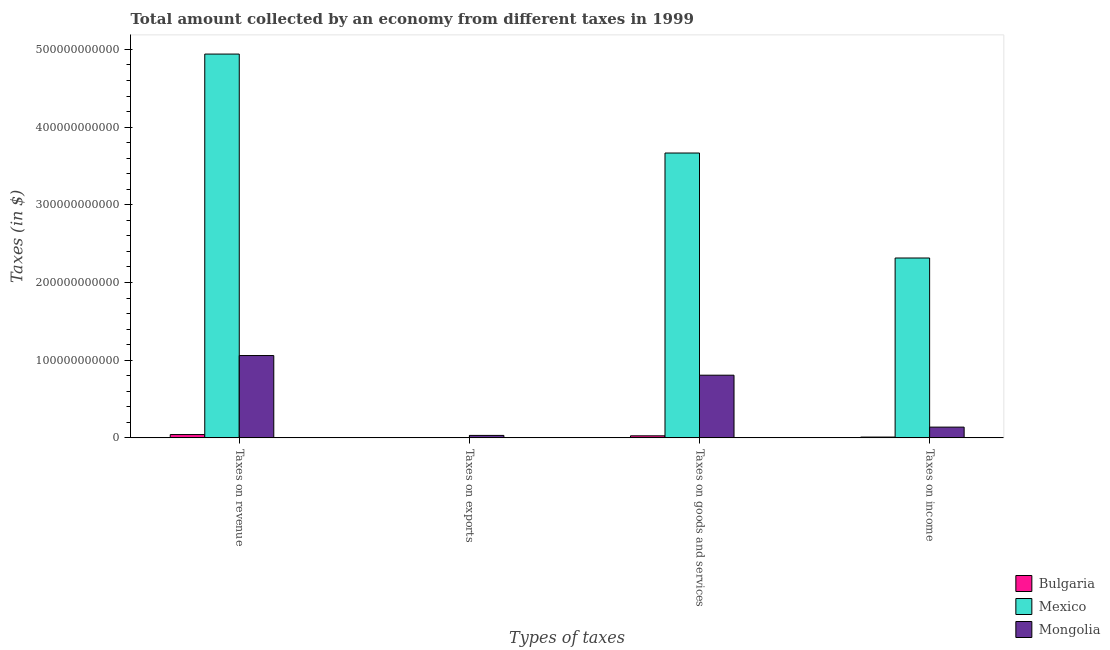How many different coloured bars are there?
Give a very brief answer. 3. How many groups of bars are there?
Your response must be concise. 4. How many bars are there on the 1st tick from the left?
Offer a terse response. 3. How many bars are there on the 1st tick from the right?
Provide a succinct answer. 3. What is the label of the 2nd group of bars from the left?
Keep it short and to the point. Taxes on exports. What is the amount collected as tax on revenue in Mongolia?
Your answer should be compact. 1.06e+11. Across all countries, what is the maximum amount collected as tax on goods?
Give a very brief answer. 3.67e+11. Across all countries, what is the minimum amount collected as tax on income?
Your answer should be compact. 1.03e+09. In which country was the amount collected as tax on exports minimum?
Offer a terse response. Bulgaria. What is the total amount collected as tax on exports in the graph?
Keep it short and to the point. 3.16e+09. What is the difference between the amount collected as tax on income in Mexico and that in Bulgaria?
Your response must be concise. 2.30e+11. What is the difference between the amount collected as tax on goods in Mexico and the amount collected as tax on income in Bulgaria?
Provide a succinct answer. 3.66e+11. What is the average amount collected as tax on revenue per country?
Offer a terse response. 2.01e+11. What is the difference between the amount collected as tax on income and amount collected as tax on revenue in Mongolia?
Ensure brevity in your answer.  -9.21e+1. What is the ratio of the amount collected as tax on income in Bulgaria to that in Mexico?
Make the answer very short. 0. What is the difference between the highest and the second highest amount collected as tax on revenue?
Provide a succinct answer. 3.88e+11. What is the difference between the highest and the lowest amount collected as tax on exports?
Ensure brevity in your answer.  3.16e+09. Is it the case that in every country, the sum of the amount collected as tax on exports and amount collected as tax on revenue is greater than the sum of amount collected as tax on goods and amount collected as tax on income?
Offer a very short reply. No. What does the 3rd bar from the left in Taxes on goods and services represents?
Offer a terse response. Mongolia. What does the 1st bar from the right in Taxes on income represents?
Offer a terse response. Mongolia. Is it the case that in every country, the sum of the amount collected as tax on revenue and amount collected as tax on exports is greater than the amount collected as tax on goods?
Your response must be concise. Yes. Are all the bars in the graph horizontal?
Offer a very short reply. No. What is the difference between two consecutive major ticks on the Y-axis?
Your answer should be compact. 1.00e+11. Does the graph contain grids?
Give a very brief answer. No. What is the title of the graph?
Keep it short and to the point. Total amount collected by an economy from different taxes in 1999. Does "Bhutan" appear as one of the legend labels in the graph?
Your response must be concise. No. What is the label or title of the X-axis?
Give a very brief answer. Types of taxes. What is the label or title of the Y-axis?
Your answer should be compact. Taxes (in $). What is the Taxes (in $) in Bulgaria in Taxes on revenue?
Your answer should be very brief. 4.26e+09. What is the Taxes (in $) of Mexico in Taxes on revenue?
Provide a succinct answer. 4.94e+11. What is the Taxes (in $) of Mongolia in Taxes on revenue?
Your answer should be compact. 1.06e+11. What is the Taxes (in $) in Bulgaria in Taxes on exports?
Offer a very short reply. 6.80e+04. What is the Taxes (in $) in Mexico in Taxes on exports?
Provide a short and direct response. 1.00e+06. What is the Taxes (in $) of Mongolia in Taxes on exports?
Offer a very short reply. 3.16e+09. What is the Taxes (in $) in Bulgaria in Taxes on goods and services?
Give a very brief answer. 2.63e+09. What is the Taxes (in $) of Mexico in Taxes on goods and services?
Make the answer very short. 3.67e+11. What is the Taxes (in $) of Mongolia in Taxes on goods and services?
Your answer should be very brief. 8.07e+1. What is the Taxes (in $) in Bulgaria in Taxes on income?
Provide a succinct answer. 1.03e+09. What is the Taxes (in $) in Mexico in Taxes on income?
Make the answer very short. 2.31e+11. What is the Taxes (in $) of Mongolia in Taxes on income?
Your answer should be compact. 1.38e+1. Across all Types of taxes, what is the maximum Taxes (in $) in Bulgaria?
Provide a short and direct response. 4.26e+09. Across all Types of taxes, what is the maximum Taxes (in $) of Mexico?
Offer a terse response. 4.94e+11. Across all Types of taxes, what is the maximum Taxes (in $) in Mongolia?
Offer a very short reply. 1.06e+11. Across all Types of taxes, what is the minimum Taxes (in $) of Bulgaria?
Provide a short and direct response. 6.80e+04. Across all Types of taxes, what is the minimum Taxes (in $) of Mongolia?
Give a very brief answer. 3.16e+09. What is the total Taxes (in $) in Bulgaria in the graph?
Give a very brief answer. 7.92e+09. What is the total Taxes (in $) of Mexico in the graph?
Your response must be concise. 1.09e+12. What is the total Taxes (in $) in Mongolia in the graph?
Keep it short and to the point. 2.04e+11. What is the difference between the Taxes (in $) of Bulgaria in Taxes on revenue and that in Taxes on exports?
Provide a short and direct response. 4.26e+09. What is the difference between the Taxes (in $) in Mexico in Taxes on revenue and that in Taxes on exports?
Offer a terse response. 4.94e+11. What is the difference between the Taxes (in $) in Mongolia in Taxes on revenue and that in Taxes on exports?
Your answer should be compact. 1.03e+11. What is the difference between the Taxes (in $) in Bulgaria in Taxes on revenue and that in Taxes on goods and services?
Ensure brevity in your answer.  1.63e+09. What is the difference between the Taxes (in $) of Mexico in Taxes on revenue and that in Taxes on goods and services?
Ensure brevity in your answer.  1.27e+11. What is the difference between the Taxes (in $) of Mongolia in Taxes on revenue and that in Taxes on goods and services?
Make the answer very short. 2.53e+1. What is the difference between the Taxes (in $) of Bulgaria in Taxes on revenue and that in Taxes on income?
Provide a short and direct response. 3.23e+09. What is the difference between the Taxes (in $) of Mexico in Taxes on revenue and that in Taxes on income?
Your answer should be compact. 2.62e+11. What is the difference between the Taxes (in $) of Mongolia in Taxes on revenue and that in Taxes on income?
Your answer should be very brief. 9.21e+1. What is the difference between the Taxes (in $) in Bulgaria in Taxes on exports and that in Taxes on goods and services?
Make the answer very short. -2.63e+09. What is the difference between the Taxes (in $) in Mexico in Taxes on exports and that in Taxes on goods and services?
Keep it short and to the point. -3.67e+11. What is the difference between the Taxes (in $) of Mongolia in Taxes on exports and that in Taxes on goods and services?
Provide a succinct answer. -7.75e+1. What is the difference between the Taxes (in $) of Bulgaria in Taxes on exports and that in Taxes on income?
Provide a short and direct response. -1.03e+09. What is the difference between the Taxes (in $) in Mexico in Taxes on exports and that in Taxes on income?
Offer a very short reply. -2.31e+11. What is the difference between the Taxes (in $) in Mongolia in Taxes on exports and that in Taxes on income?
Your answer should be compact. -1.07e+1. What is the difference between the Taxes (in $) of Bulgaria in Taxes on goods and services and that in Taxes on income?
Offer a very short reply. 1.60e+09. What is the difference between the Taxes (in $) of Mexico in Taxes on goods and services and that in Taxes on income?
Offer a very short reply. 1.35e+11. What is the difference between the Taxes (in $) of Mongolia in Taxes on goods and services and that in Taxes on income?
Keep it short and to the point. 6.68e+1. What is the difference between the Taxes (in $) in Bulgaria in Taxes on revenue and the Taxes (in $) in Mexico in Taxes on exports?
Provide a short and direct response. 4.26e+09. What is the difference between the Taxes (in $) in Bulgaria in Taxes on revenue and the Taxes (in $) in Mongolia in Taxes on exports?
Make the answer very short. 1.10e+09. What is the difference between the Taxes (in $) in Mexico in Taxes on revenue and the Taxes (in $) in Mongolia in Taxes on exports?
Offer a terse response. 4.91e+11. What is the difference between the Taxes (in $) of Bulgaria in Taxes on revenue and the Taxes (in $) of Mexico in Taxes on goods and services?
Keep it short and to the point. -3.62e+11. What is the difference between the Taxes (in $) in Bulgaria in Taxes on revenue and the Taxes (in $) in Mongolia in Taxes on goods and services?
Your answer should be compact. -7.64e+1. What is the difference between the Taxes (in $) in Mexico in Taxes on revenue and the Taxes (in $) in Mongolia in Taxes on goods and services?
Ensure brevity in your answer.  4.13e+11. What is the difference between the Taxes (in $) of Bulgaria in Taxes on revenue and the Taxes (in $) of Mexico in Taxes on income?
Your answer should be very brief. -2.27e+11. What is the difference between the Taxes (in $) of Bulgaria in Taxes on revenue and the Taxes (in $) of Mongolia in Taxes on income?
Your response must be concise. -9.58e+09. What is the difference between the Taxes (in $) in Mexico in Taxes on revenue and the Taxes (in $) in Mongolia in Taxes on income?
Your answer should be compact. 4.80e+11. What is the difference between the Taxes (in $) in Bulgaria in Taxes on exports and the Taxes (in $) in Mexico in Taxes on goods and services?
Provide a succinct answer. -3.67e+11. What is the difference between the Taxes (in $) in Bulgaria in Taxes on exports and the Taxes (in $) in Mongolia in Taxes on goods and services?
Offer a terse response. -8.07e+1. What is the difference between the Taxes (in $) of Mexico in Taxes on exports and the Taxes (in $) of Mongolia in Taxes on goods and services?
Provide a short and direct response. -8.07e+1. What is the difference between the Taxes (in $) in Bulgaria in Taxes on exports and the Taxes (in $) in Mexico in Taxes on income?
Offer a terse response. -2.31e+11. What is the difference between the Taxes (in $) of Bulgaria in Taxes on exports and the Taxes (in $) of Mongolia in Taxes on income?
Your answer should be compact. -1.38e+1. What is the difference between the Taxes (in $) in Mexico in Taxes on exports and the Taxes (in $) in Mongolia in Taxes on income?
Give a very brief answer. -1.38e+1. What is the difference between the Taxes (in $) in Bulgaria in Taxes on goods and services and the Taxes (in $) in Mexico in Taxes on income?
Your answer should be compact. -2.29e+11. What is the difference between the Taxes (in $) in Bulgaria in Taxes on goods and services and the Taxes (in $) in Mongolia in Taxes on income?
Offer a very short reply. -1.12e+1. What is the difference between the Taxes (in $) in Mexico in Taxes on goods and services and the Taxes (in $) in Mongolia in Taxes on income?
Ensure brevity in your answer.  3.53e+11. What is the average Taxes (in $) of Bulgaria per Types of taxes?
Keep it short and to the point. 1.98e+09. What is the average Taxes (in $) of Mexico per Types of taxes?
Keep it short and to the point. 2.73e+11. What is the average Taxes (in $) of Mongolia per Types of taxes?
Offer a very short reply. 5.09e+1. What is the difference between the Taxes (in $) of Bulgaria and Taxes (in $) of Mexico in Taxes on revenue?
Your response must be concise. -4.90e+11. What is the difference between the Taxes (in $) in Bulgaria and Taxes (in $) in Mongolia in Taxes on revenue?
Ensure brevity in your answer.  -1.02e+11. What is the difference between the Taxes (in $) of Mexico and Taxes (in $) of Mongolia in Taxes on revenue?
Provide a succinct answer. 3.88e+11. What is the difference between the Taxes (in $) of Bulgaria and Taxes (in $) of Mexico in Taxes on exports?
Your response must be concise. -9.32e+05. What is the difference between the Taxes (in $) in Bulgaria and Taxes (in $) in Mongolia in Taxes on exports?
Provide a short and direct response. -3.16e+09. What is the difference between the Taxes (in $) of Mexico and Taxes (in $) of Mongolia in Taxes on exports?
Offer a very short reply. -3.16e+09. What is the difference between the Taxes (in $) in Bulgaria and Taxes (in $) in Mexico in Taxes on goods and services?
Your response must be concise. -3.64e+11. What is the difference between the Taxes (in $) in Bulgaria and Taxes (in $) in Mongolia in Taxes on goods and services?
Keep it short and to the point. -7.80e+1. What is the difference between the Taxes (in $) in Mexico and Taxes (in $) in Mongolia in Taxes on goods and services?
Provide a succinct answer. 2.86e+11. What is the difference between the Taxes (in $) of Bulgaria and Taxes (in $) of Mexico in Taxes on income?
Provide a succinct answer. -2.30e+11. What is the difference between the Taxes (in $) of Bulgaria and Taxes (in $) of Mongolia in Taxes on income?
Ensure brevity in your answer.  -1.28e+1. What is the difference between the Taxes (in $) in Mexico and Taxes (in $) in Mongolia in Taxes on income?
Your answer should be compact. 2.18e+11. What is the ratio of the Taxes (in $) in Bulgaria in Taxes on revenue to that in Taxes on exports?
Give a very brief answer. 6.27e+04. What is the ratio of the Taxes (in $) in Mexico in Taxes on revenue to that in Taxes on exports?
Give a very brief answer. 4.94e+05. What is the ratio of the Taxes (in $) in Mongolia in Taxes on revenue to that in Taxes on exports?
Your response must be concise. 33.52. What is the ratio of the Taxes (in $) of Bulgaria in Taxes on revenue to that in Taxes on goods and services?
Give a very brief answer. 1.62. What is the ratio of the Taxes (in $) of Mexico in Taxes on revenue to that in Taxes on goods and services?
Give a very brief answer. 1.35. What is the ratio of the Taxes (in $) in Mongolia in Taxes on revenue to that in Taxes on goods and services?
Ensure brevity in your answer.  1.31. What is the ratio of the Taxes (in $) in Bulgaria in Taxes on revenue to that in Taxes on income?
Your answer should be very brief. 4.14. What is the ratio of the Taxes (in $) in Mexico in Taxes on revenue to that in Taxes on income?
Provide a short and direct response. 2.13. What is the ratio of the Taxes (in $) of Mongolia in Taxes on revenue to that in Taxes on income?
Offer a terse response. 7.65. What is the ratio of the Taxes (in $) of Bulgaria in Taxes on exports to that in Taxes on goods and services?
Your answer should be very brief. 0. What is the ratio of the Taxes (in $) in Mongolia in Taxes on exports to that in Taxes on goods and services?
Make the answer very short. 0.04. What is the ratio of the Taxes (in $) of Bulgaria in Taxes on exports to that in Taxes on income?
Give a very brief answer. 0. What is the ratio of the Taxes (in $) in Mexico in Taxes on exports to that in Taxes on income?
Your answer should be compact. 0. What is the ratio of the Taxes (in $) in Mongolia in Taxes on exports to that in Taxes on income?
Make the answer very short. 0.23. What is the ratio of the Taxes (in $) in Bulgaria in Taxes on goods and services to that in Taxes on income?
Your answer should be very brief. 2.56. What is the ratio of the Taxes (in $) in Mexico in Taxes on goods and services to that in Taxes on income?
Ensure brevity in your answer.  1.58. What is the ratio of the Taxes (in $) in Mongolia in Taxes on goods and services to that in Taxes on income?
Offer a terse response. 5.83. What is the difference between the highest and the second highest Taxes (in $) in Bulgaria?
Make the answer very short. 1.63e+09. What is the difference between the highest and the second highest Taxes (in $) of Mexico?
Offer a terse response. 1.27e+11. What is the difference between the highest and the second highest Taxes (in $) of Mongolia?
Your answer should be very brief. 2.53e+1. What is the difference between the highest and the lowest Taxes (in $) of Bulgaria?
Your answer should be compact. 4.26e+09. What is the difference between the highest and the lowest Taxes (in $) of Mexico?
Make the answer very short. 4.94e+11. What is the difference between the highest and the lowest Taxes (in $) of Mongolia?
Provide a succinct answer. 1.03e+11. 